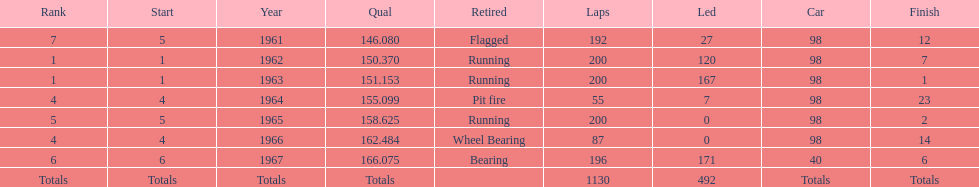What is the most common cause for a retired car? Running. 